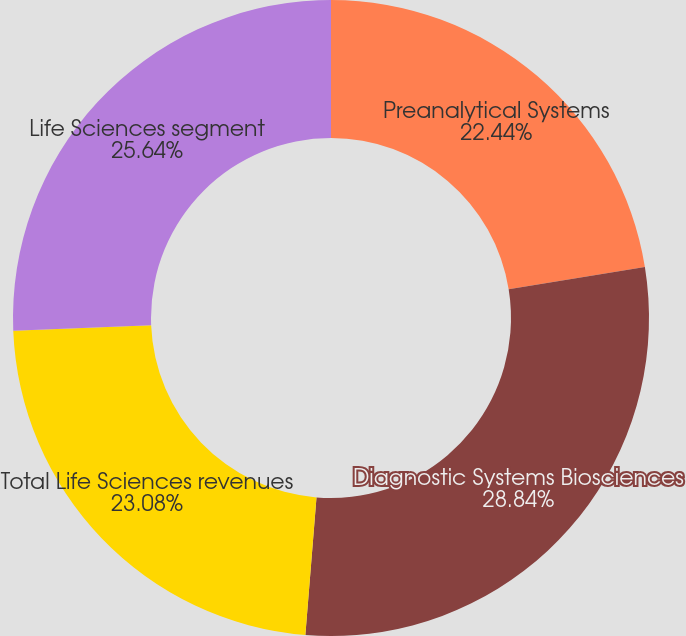<chart> <loc_0><loc_0><loc_500><loc_500><pie_chart><fcel>Preanalytical Systems<fcel>Diagnostic Systems Biosciences<fcel>Total Life Sciences revenues<fcel>Life Sciences segment<nl><fcel>22.44%<fcel>28.85%<fcel>23.08%<fcel>25.64%<nl></chart> 